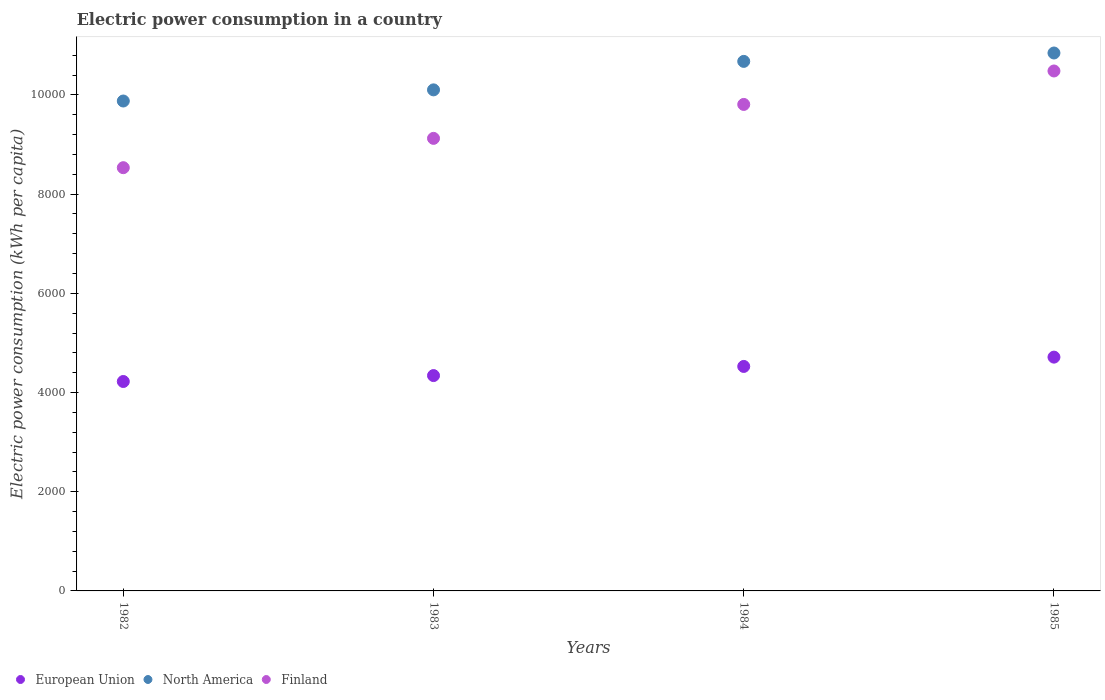Is the number of dotlines equal to the number of legend labels?
Provide a short and direct response. Yes. What is the electric power consumption in in North America in 1984?
Provide a succinct answer. 1.07e+04. Across all years, what is the maximum electric power consumption in in Finland?
Your response must be concise. 1.05e+04. Across all years, what is the minimum electric power consumption in in North America?
Make the answer very short. 9877.34. What is the total electric power consumption in in Finland in the graph?
Provide a succinct answer. 3.79e+04. What is the difference between the electric power consumption in in North America in 1982 and that in 1985?
Your response must be concise. -968.06. What is the difference between the electric power consumption in in European Union in 1984 and the electric power consumption in in Finland in 1982?
Keep it short and to the point. -4007.14. What is the average electric power consumption in in North America per year?
Your answer should be compact. 1.04e+04. In the year 1982, what is the difference between the electric power consumption in in North America and electric power consumption in in Finland?
Make the answer very short. 1344.18. What is the ratio of the electric power consumption in in North America in 1983 to that in 1985?
Make the answer very short. 0.93. Is the difference between the electric power consumption in in North America in 1983 and 1984 greater than the difference between the electric power consumption in in Finland in 1983 and 1984?
Provide a short and direct response. Yes. What is the difference between the highest and the second highest electric power consumption in in North America?
Keep it short and to the point. 169.13. What is the difference between the highest and the lowest electric power consumption in in European Union?
Ensure brevity in your answer.  491.26. In how many years, is the electric power consumption in in North America greater than the average electric power consumption in in North America taken over all years?
Your answer should be very brief. 2. Is it the case that in every year, the sum of the electric power consumption in in Finland and electric power consumption in in North America  is greater than the electric power consumption in in European Union?
Offer a terse response. Yes. Does the electric power consumption in in Finland monotonically increase over the years?
Your answer should be compact. Yes. Is the electric power consumption in in North America strictly greater than the electric power consumption in in European Union over the years?
Your response must be concise. Yes. Is the electric power consumption in in Finland strictly less than the electric power consumption in in North America over the years?
Provide a succinct answer. Yes. Where does the legend appear in the graph?
Your answer should be compact. Bottom left. How are the legend labels stacked?
Ensure brevity in your answer.  Horizontal. What is the title of the graph?
Offer a terse response. Electric power consumption in a country. What is the label or title of the X-axis?
Provide a succinct answer. Years. What is the label or title of the Y-axis?
Give a very brief answer. Electric power consumption (kWh per capita). What is the Electric power consumption (kWh per capita) in European Union in 1982?
Your response must be concise. 4222.33. What is the Electric power consumption (kWh per capita) in North America in 1982?
Make the answer very short. 9877.34. What is the Electric power consumption (kWh per capita) of Finland in 1982?
Offer a very short reply. 8533.16. What is the Electric power consumption (kWh per capita) in European Union in 1983?
Your answer should be compact. 4341.66. What is the Electric power consumption (kWh per capita) in North America in 1983?
Keep it short and to the point. 1.01e+04. What is the Electric power consumption (kWh per capita) of Finland in 1983?
Your answer should be compact. 9124.16. What is the Electric power consumption (kWh per capita) in European Union in 1984?
Make the answer very short. 4526.02. What is the Electric power consumption (kWh per capita) of North America in 1984?
Ensure brevity in your answer.  1.07e+04. What is the Electric power consumption (kWh per capita) of Finland in 1984?
Provide a succinct answer. 9808.47. What is the Electric power consumption (kWh per capita) of European Union in 1985?
Offer a terse response. 4713.59. What is the Electric power consumption (kWh per capita) of North America in 1985?
Keep it short and to the point. 1.08e+04. What is the Electric power consumption (kWh per capita) in Finland in 1985?
Your response must be concise. 1.05e+04. Across all years, what is the maximum Electric power consumption (kWh per capita) of European Union?
Keep it short and to the point. 4713.59. Across all years, what is the maximum Electric power consumption (kWh per capita) of North America?
Provide a short and direct response. 1.08e+04. Across all years, what is the maximum Electric power consumption (kWh per capita) of Finland?
Provide a short and direct response. 1.05e+04. Across all years, what is the minimum Electric power consumption (kWh per capita) in European Union?
Your response must be concise. 4222.33. Across all years, what is the minimum Electric power consumption (kWh per capita) of North America?
Give a very brief answer. 9877.34. Across all years, what is the minimum Electric power consumption (kWh per capita) in Finland?
Provide a succinct answer. 8533.16. What is the total Electric power consumption (kWh per capita) of European Union in the graph?
Provide a succinct answer. 1.78e+04. What is the total Electric power consumption (kWh per capita) of North America in the graph?
Your answer should be very brief. 4.15e+04. What is the total Electric power consumption (kWh per capita) in Finland in the graph?
Offer a terse response. 3.79e+04. What is the difference between the Electric power consumption (kWh per capita) in European Union in 1982 and that in 1983?
Provide a succinct answer. -119.32. What is the difference between the Electric power consumption (kWh per capita) of North America in 1982 and that in 1983?
Give a very brief answer. -224.8. What is the difference between the Electric power consumption (kWh per capita) in Finland in 1982 and that in 1983?
Provide a short and direct response. -591. What is the difference between the Electric power consumption (kWh per capita) of European Union in 1982 and that in 1984?
Make the answer very short. -303.69. What is the difference between the Electric power consumption (kWh per capita) of North America in 1982 and that in 1984?
Keep it short and to the point. -798.93. What is the difference between the Electric power consumption (kWh per capita) of Finland in 1982 and that in 1984?
Your answer should be compact. -1275.3. What is the difference between the Electric power consumption (kWh per capita) in European Union in 1982 and that in 1985?
Give a very brief answer. -491.26. What is the difference between the Electric power consumption (kWh per capita) in North America in 1982 and that in 1985?
Ensure brevity in your answer.  -968.06. What is the difference between the Electric power consumption (kWh per capita) in Finland in 1982 and that in 1985?
Provide a succinct answer. -1949.67. What is the difference between the Electric power consumption (kWh per capita) of European Union in 1983 and that in 1984?
Give a very brief answer. -184.37. What is the difference between the Electric power consumption (kWh per capita) in North America in 1983 and that in 1984?
Provide a succinct answer. -574.13. What is the difference between the Electric power consumption (kWh per capita) of Finland in 1983 and that in 1984?
Your answer should be very brief. -684.3. What is the difference between the Electric power consumption (kWh per capita) in European Union in 1983 and that in 1985?
Your answer should be compact. -371.93. What is the difference between the Electric power consumption (kWh per capita) of North America in 1983 and that in 1985?
Provide a succinct answer. -743.26. What is the difference between the Electric power consumption (kWh per capita) in Finland in 1983 and that in 1985?
Offer a very short reply. -1358.67. What is the difference between the Electric power consumption (kWh per capita) in European Union in 1984 and that in 1985?
Your answer should be compact. -187.57. What is the difference between the Electric power consumption (kWh per capita) in North America in 1984 and that in 1985?
Provide a short and direct response. -169.13. What is the difference between the Electric power consumption (kWh per capita) of Finland in 1984 and that in 1985?
Make the answer very short. -674.37. What is the difference between the Electric power consumption (kWh per capita) of European Union in 1982 and the Electric power consumption (kWh per capita) of North America in 1983?
Ensure brevity in your answer.  -5879.81. What is the difference between the Electric power consumption (kWh per capita) in European Union in 1982 and the Electric power consumption (kWh per capita) in Finland in 1983?
Ensure brevity in your answer.  -4901.83. What is the difference between the Electric power consumption (kWh per capita) of North America in 1982 and the Electric power consumption (kWh per capita) of Finland in 1983?
Your answer should be very brief. 753.18. What is the difference between the Electric power consumption (kWh per capita) of European Union in 1982 and the Electric power consumption (kWh per capita) of North America in 1984?
Your answer should be compact. -6453.94. What is the difference between the Electric power consumption (kWh per capita) in European Union in 1982 and the Electric power consumption (kWh per capita) in Finland in 1984?
Offer a terse response. -5586.13. What is the difference between the Electric power consumption (kWh per capita) of North America in 1982 and the Electric power consumption (kWh per capita) of Finland in 1984?
Offer a terse response. 68.87. What is the difference between the Electric power consumption (kWh per capita) in European Union in 1982 and the Electric power consumption (kWh per capita) in North America in 1985?
Your answer should be compact. -6623.07. What is the difference between the Electric power consumption (kWh per capita) in European Union in 1982 and the Electric power consumption (kWh per capita) in Finland in 1985?
Ensure brevity in your answer.  -6260.5. What is the difference between the Electric power consumption (kWh per capita) in North America in 1982 and the Electric power consumption (kWh per capita) in Finland in 1985?
Make the answer very short. -605.49. What is the difference between the Electric power consumption (kWh per capita) in European Union in 1983 and the Electric power consumption (kWh per capita) in North America in 1984?
Offer a very short reply. -6334.61. What is the difference between the Electric power consumption (kWh per capita) of European Union in 1983 and the Electric power consumption (kWh per capita) of Finland in 1984?
Provide a succinct answer. -5466.81. What is the difference between the Electric power consumption (kWh per capita) of North America in 1983 and the Electric power consumption (kWh per capita) of Finland in 1984?
Provide a short and direct response. 293.68. What is the difference between the Electric power consumption (kWh per capita) in European Union in 1983 and the Electric power consumption (kWh per capita) in North America in 1985?
Make the answer very short. -6503.75. What is the difference between the Electric power consumption (kWh per capita) in European Union in 1983 and the Electric power consumption (kWh per capita) in Finland in 1985?
Your response must be concise. -6141.17. What is the difference between the Electric power consumption (kWh per capita) of North America in 1983 and the Electric power consumption (kWh per capita) of Finland in 1985?
Your answer should be compact. -380.69. What is the difference between the Electric power consumption (kWh per capita) in European Union in 1984 and the Electric power consumption (kWh per capita) in North America in 1985?
Offer a very short reply. -6319.38. What is the difference between the Electric power consumption (kWh per capita) in European Union in 1984 and the Electric power consumption (kWh per capita) in Finland in 1985?
Your response must be concise. -5956.81. What is the difference between the Electric power consumption (kWh per capita) in North America in 1984 and the Electric power consumption (kWh per capita) in Finland in 1985?
Ensure brevity in your answer.  193.44. What is the average Electric power consumption (kWh per capita) in European Union per year?
Offer a terse response. 4450.9. What is the average Electric power consumption (kWh per capita) of North America per year?
Your answer should be very brief. 1.04e+04. What is the average Electric power consumption (kWh per capita) in Finland per year?
Make the answer very short. 9487.16. In the year 1982, what is the difference between the Electric power consumption (kWh per capita) in European Union and Electric power consumption (kWh per capita) in North America?
Give a very brief answer. -5655.01. In the year 1982, what is the difference between the Electric power consumption (kWh per capita) in European Union and Electric power consumption (kWh per capita) in Finland?
Your response must be concise. -4310.83. In the year 1982, what is the difference between the Electric power consumption (kWh per capita) in North America and Electric power consumption (kWh per capita) in Finland?
Your answer should be compact. 1344.18. In the year 1983, what is the difference between the Electric power consumption (kWh per capita) of European Union and Electric power consumption (kWh per capita) of North America?
Your answer should be compact. -5760.49. In the year 1983, what is the difference between the Electric power consumption (kWh per capita) of European Union and Electric power consumption (kWh per capita) of Finland?
Provide a short and direct response. -4782.51. In the year 1983, what is the difference between the Electric power consumption (kWh per capita) of North America and Electric power consumption (kWh per capita) of Finland?
Your answer should be compact. 977.98. In the year 1984, what is the difference between the Electric power consumption (kWh per capita) in European Union and Electric power consumption (kWh per capita) in North America?
Make the answer very short. -6150.25. In the year 1984, what is the difference between the Electric power consumption (kWh per capita) in European Union and Electric power consumption (kWh per capita) in Finland?
Provide a succinct answer. -5282.44. In the year 1984, what is the difference between the Electric power consumption (kWh per capita) in North America and Electric power consumption (kWh per capita) in Finland?
Provide a short and direct response. 867.8. In the year 1985, what is the difference between the Electric power consumption (kWh per capita) of European Union and Electric power consumption (kWh per capita) of North America?
Give a very brief answer. -6131.81. In the year 1985, what is the difference between the Electric power consumption (kWh per capita) of European Union and Electric power consumption (kWh per capita) of Finland?
Provide a short and direct response. -5769.24. In the year 1985, what is the difference between the Electric power consumption (kWh per capita) of North America and Electric power consumption (kWh per capita) of Finland?
Your answer should be compact. 362.57. What is the ratio of the Electric power consumption (kWh per capita) in European Union in 1982 to that in 1983?
Ensure brevity in your answer.  0.97. What is the ratio of the Electric power consumption (kWh per capita) in North America in 1982 to that in 1983?
Your answer should be very brief. 0.98. What is the ratio of the Electric power consumption (kWh per capita) of Finland in 1982 to that in 1983?
Your answer should be very brief. 0.94. What is the ratio of the Electric power consumption (kWh per capita) in European Union in 1982 to that in 1984?
Make the answer very short. 0.93. What is the ratio of the Electric power consumption (kWh per capita) of North America in 1982 to that in 1984?
Your response must be concise. 0.93. What is the ratio of the Electric power consumption (kWh per capita) in Finland in 1982 to that in 1984?
Your answer should be very brief. 0.87. What is the ratio of the Electric power consumption (kWh per capita) in European Union in 1982 to that in 1985?
Your answer should be very brief. 0.9. What is the ratio of the Electric power consumption (kWh per capita) of North America in 1982 to that in 1985?
Make the answer very short. 0.91. What is the ratio of the Electric power consumption (kWh per capita) of Finland in 1982 to that in 1985?
Your response must be concise. 0.81. What is the ratio of the Electric power consumption (kWh per capita) of European Union in 1983 to that in 1984?
Offer a very short reply. 0.96. What is the ratio of the Electric power consumption (kWh per capita) of North America in 1983 to that in 1984?
Offer a very short reply. 0.95. What is the ratio of the Electric power consumption (kWh per capita) of Finland in 1983 to that in 1984?
Provide a short and direct response. 0.93. What is the ratio of the Electric power consumption (kWh per capita) of European Union in 1983 to that in 1985?
Your answer should be very brief. 0.92. What is the ratio of the Electric power consumption (kWh per capita) of North America in 1983 to that in 1985?
Your answer should be compact. 0.93. What is the ratio of the Electric power consumption (kWh per capita) of Finland in 1983 to that in 1985?
Your response must be concise. 0.87. What is the ratio of the Electric power consumption (kWh per capita) of European Union in 1984 to that in 1985?
Offer a terse response. 0.96. What is the ratio of the Electric power consumption (kWh per capita) of North America in 1984 to that in 1985?
Your answer should be very brief. 0.98. What is the ratio of the Electric power consumption (kWh per capita) in Finland in 1984 to that in 1985?
Your response must be concise. 0.94. What is the difference between the highest and the second highest Electric power consumption (kWh per capita) of European Union?
Offer a very short reply. 187.57. What is the difference between the highest and the second highest Electric power consumption (kWh per capita) in North America?
Your answer should be very brief. 169.13. What is the difference between the highest and the second highest Electric power consumption (kWh per capita) in Finland?
Make the answer very short. 674.37. What is the difference between the highest and the lowest Electric power consumption (kWh per capita) of European Union?
Your answer should be compact. 491.26. What is the difference between the highest and the lowest Electric power consumption (kWh per capita) of North America?
Provide a succinct answer. 968.06. What is the difference between the highest and the lowest Electric power consumption (kWh per capita) in Finland?
Make the answer very short. 1949.67. 